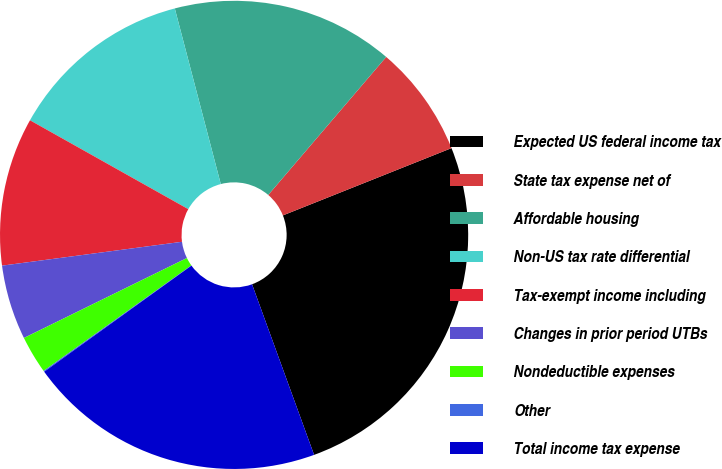Convert chart to OTSL. <chart><loc_0><loc_0><loc_500><loc_500><pie_chart><fcel>Expected US federal income tax<fcel>State tax expense net of<fcel>Affordable housing<fcel>Non-US tax rate differential<fcel>Tax-exempt income including<fcel>Changes in prior period UTBs<fcel>Nondeductible expenses<fcel>Other<fcel>Total income tax expense<nl><fcel>25.49%<fcel>7.7%<fcel>15.33%<fcel>12.78%<fcel>10.24%<fcel>5.16%<fcel>2.61%<fcel>0.07%<fcel>20.61%<nl></chart> 